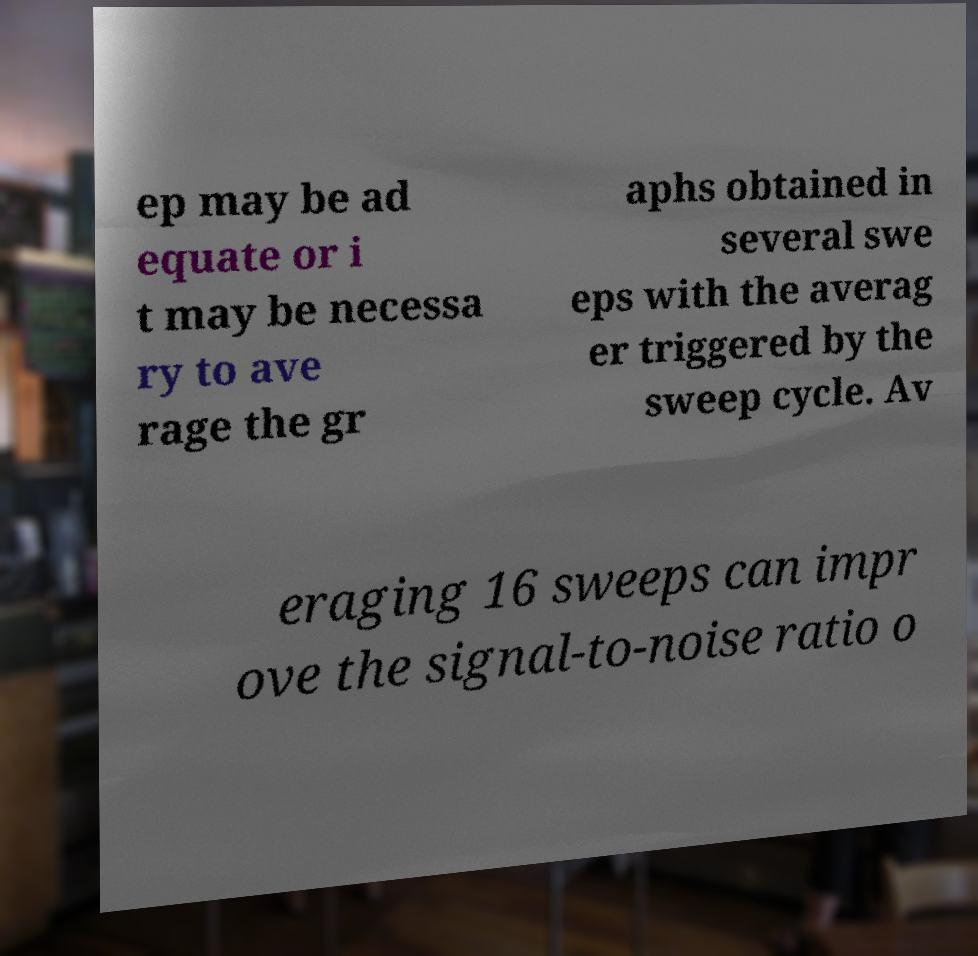Can you accurately transcribe the text from the provided image for me? ep may be ad equate or i t may be necessa ry to ave rage the gr aphs obtained in several swe eps with the averag er triggered by the sweep cycle. Av eraging 16 sweeps can impr ove the signal-to-noise ratio o 